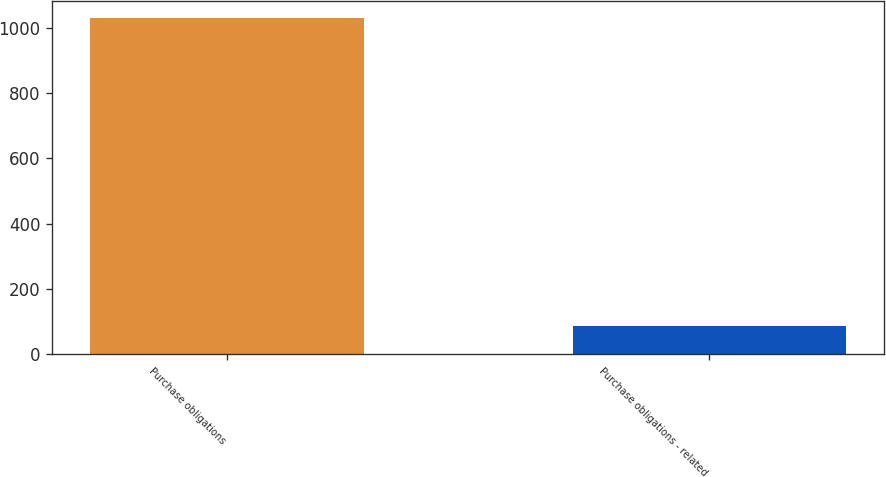Convert chart. <chart><loc_0><loc_0><loc_500><loc_500><bar_chart><fcel>Purchase obligations<fcel>Purchase obligations - related<nl><fcel>1032<fcel>86<nl></chart> 